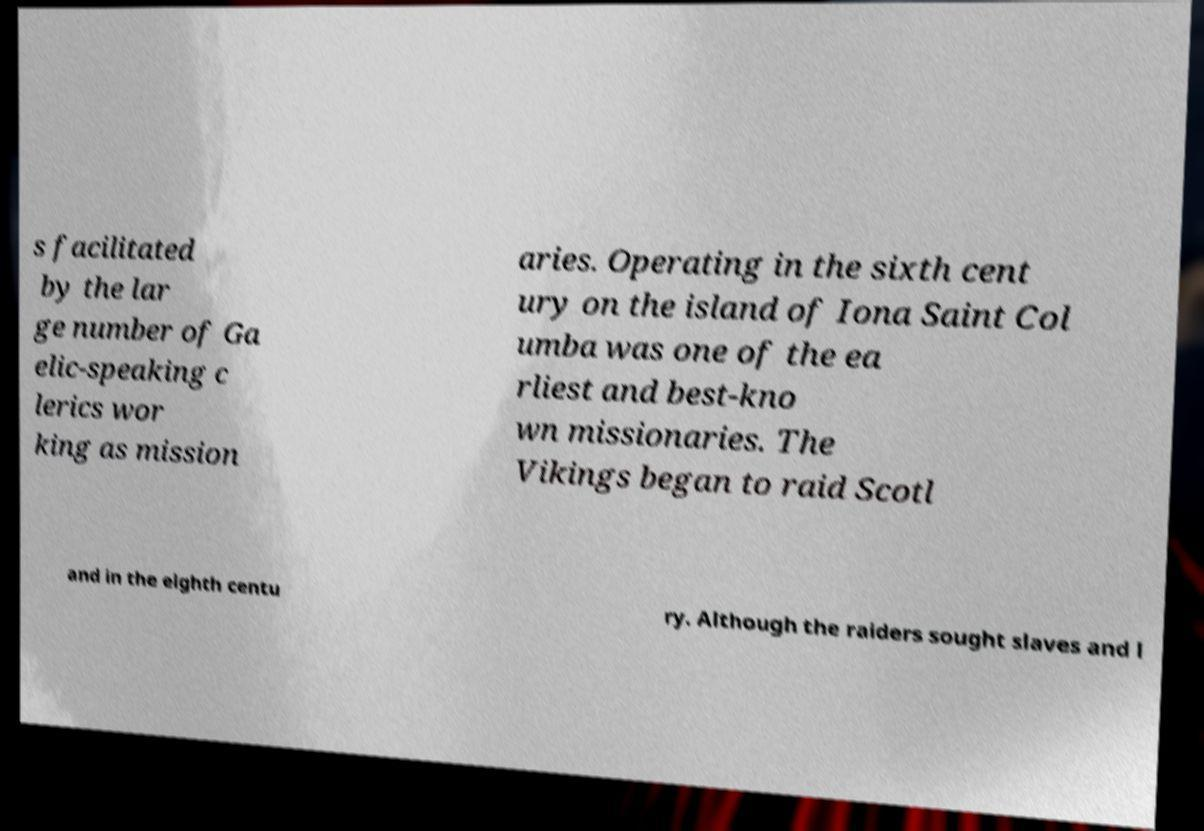Can you read and provide the text displayed in the image?This photo seems to have some interesting text. Can you extract and type it out for me? s facilitated by the lar ge number of Ga elic-speaking c lerics wor king as mission aries. Operating in the sixth cent ury on the island of Iona Saint Col umba was one of the ea rliest and best-kno wn missionaries. The Vikings began to raid Scotl and in the eighth centu ry. Although the raiders sought slaves and l 